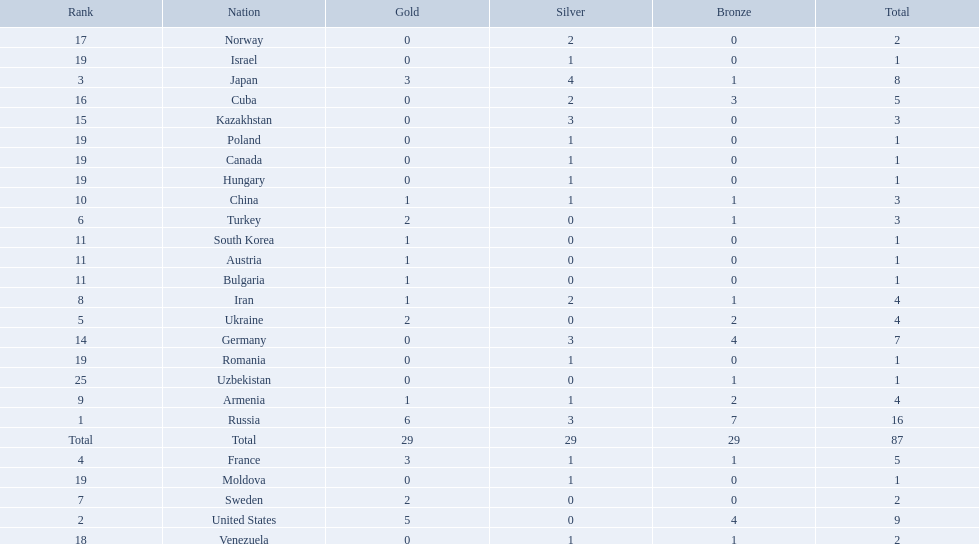Which nations are there? Russia, 6, United States, 5, Japan, 3, France, 3, Ukraine, 2, Turkey, 2, Sweden, 2, Iran, 1, Armenia, 1, China, 1, Austria, 1, Bulgaria, 1, South Korea, 1, Germany, 0, Kazakhstan, 0, Cuba, 0, Norway, 0, Venezuela, 0, Canada, 0, Hungary, 0, Israel, 0, Moldova, 0, Poland, 0, Romania, 0, Uzbekistan, 0. Which nations won gold? Russia, 6, United States, 5, Japan, 3, France, 3, Ukraine, 2, Turkey, 2, Sweden, 2, Iran, 1, Armenia, 1, China, 1, Austria, 1, Bulgaria, 1, South Korea, 1. How many golds did united states win? United States, 5. Which country has more than 5 gold medals? Russia, 6. What country is it? Russia. How many gold medals did the united states win? 5. Who won more than 5 gold medals? Russia. Which nations only won less then 5 medals? Ukraine, Turkey, Sweden, Iran, Armenia, China, Austria, Bulgaria, South Korea, Germany, Kazakhstan, Norway, Venezuela, Canada, Hungary, Israel, Moldova, Poland, Romania, Uzbekistan. Which of these were not asian nations? Ukraine, Turkey, Sweden, Iran, Armenia, Austria, Bulgaria, Germany, Kazakhstan, Norway, Venezuela, Canada, Hungary, Israel, Moldova, Poland, Romania, Uzbekistan. Which of those did not win any silver medals? Ukraine, Turkey, Sweden, Austria, Bulgaria, Uzbekistan. Which ones of these had only one medal total? Austria, Bulgaria, Uzbekistan. Can you give me this table as a dict? {'header': ['Rank', 'Nation', 'Gold', 'Silver', 'Bronze', 'Total'], 'rows': [['17', 'Norway', '0', '2', '0', '2'], ['19', 'Israel', '0', '1', '0', '1'], ['3', 'Japan', '3', '4', '1', '8'], ['16', 'Cuba', '0', '2', '3', '5'], ['15', 'Kazakhstan', '0', '3', '0', '3'], ['19', 'Poland', '0', '1', '0', '1'], ['19', 'Canada', '0', '1', '0', '1'], ['19', 'Hungary', '0', '1', '0', '1'], ['10', 'China', '1', '1', '1', '3'], ['6', 'Turkey', '2', '0', '1', '3'], ['11', 'South Korea', '1', '0', '0', '1'], ['11', 'Austria', '1', '0', '0', '1'], ['11', 'Bulgaria', '1', '0', '0', '1'], ['8', 'Iran', '1', '2', '1', '4'], ['5', 'Ukraine', '2', '0', '2', '4'], ['14', 'Germany', '0', '3', '4', '7'], ['19', 'Romania', '0', '1', '0', '1'], ['25', 'Uzbekistan', '0', '0', '1', '1'], ['9', 'Armenia', '1', '1', '2', '4'], ['1', 'Russia', '6', '3', '7', '16'], ['Total', 'Total', '29', '29', '29', '87'], ['4', 'France', '3', '1', '1', '5'], ['19', 'Moldova', '0', '1', '0', '1'], ['7', 'Sweden', '2', '0', '0', '2'], ['2', 'United States', '5', '0', '4', '9'], ['18', 'Venezuela', '0', '1', '1', '2']]} Which of those would be listed first alphabetically? Austria. 